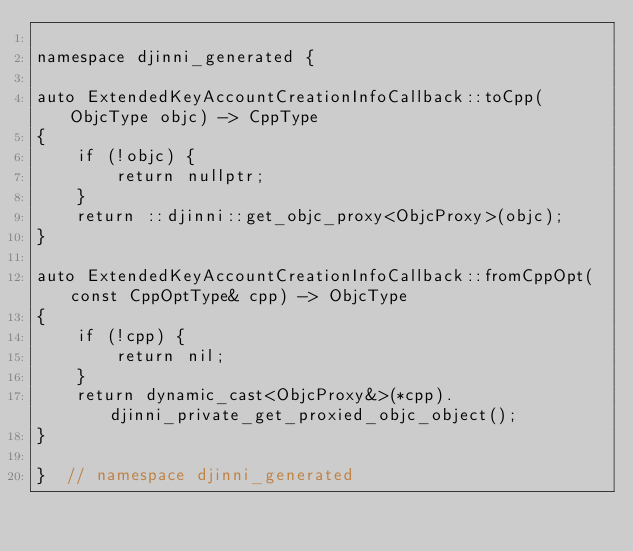<code> <loc_0><loc_0><loc_500><loc_500><_ObjectiveC_>
namespace djinni_generated {

auto ExtendedKeyAccountCreationInfoCallback::toCpp(ObjcType objc) -> CppType
{
    if (!objc) {
        return nullptr;
    }
    return ::djinni::get_objc_proxy<ObjcProxy>(objc);
}

auto ExtendedKeyAccountCreationInfoCallback::fromCppOpt(const CppOptType& cpp) -> ObjcType
{
    if (!cpp) {
        return nil;
    }
    return dynamic_cast<ObjcProxy&>(*cpp).djinni_private_get_proxied_objc_object();
}

}  // namespace djinni_generated
</code> 